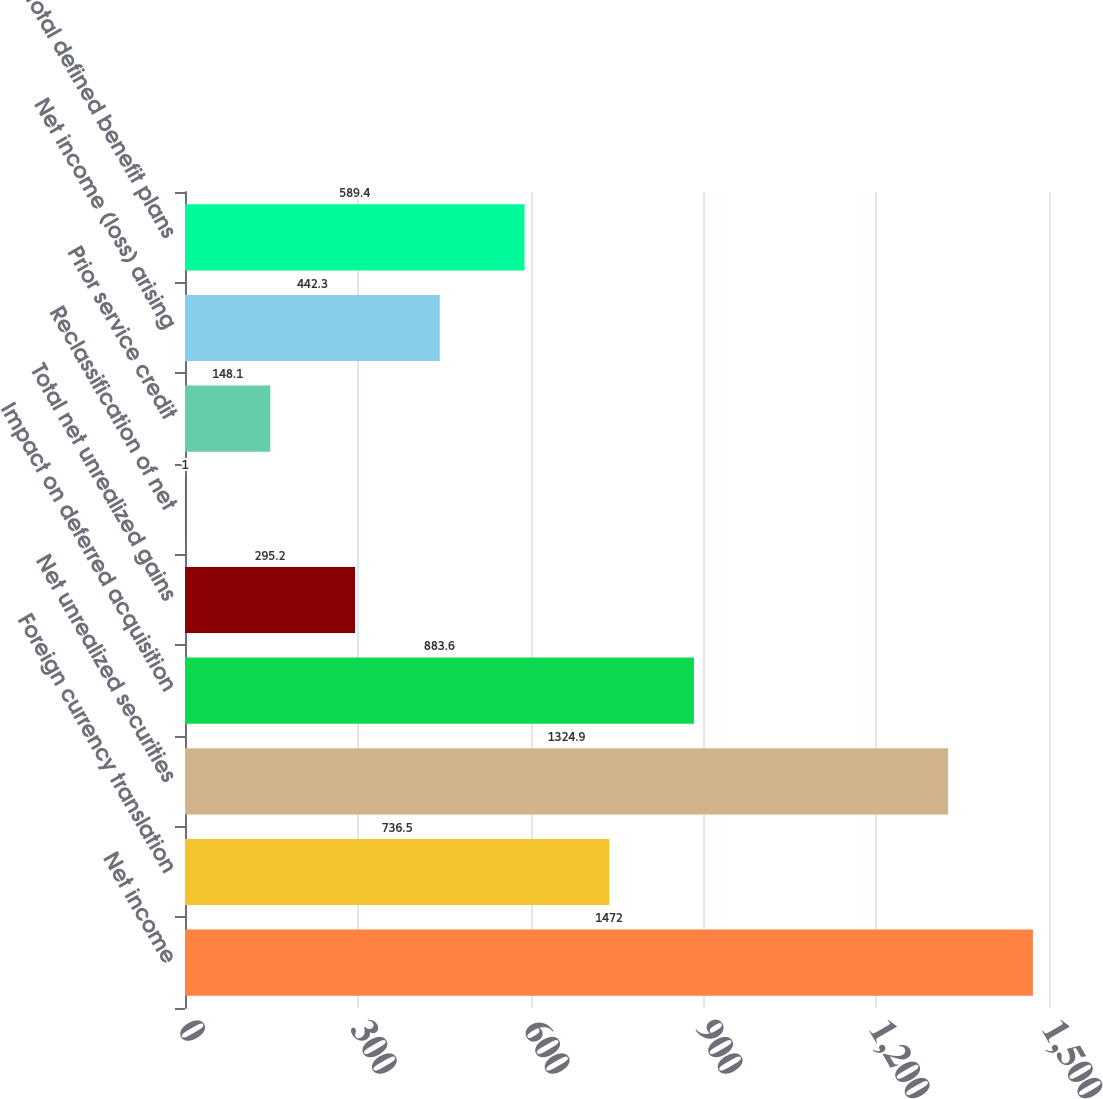Convert chart to OTSL. <chart><loc_0><loc_0><loc_500><loc_500><bar_chart><fcel>Net income<fcel>Foreign currency translation<fcel>Net unrealized securities<fcel>Impact on deferred acquisition<fcel>Total net unrealized gains<fcel>Reclassification of net<fcel>Prior service credit<fcel>Net income (loss) arising<fcel>Total defined benefit plans<nl><fcel>1472<fcel>736.5<fcel>1324.9<fcel>883.6<fcel>295.2<fcel>1<fcel>148.1<fcel>442.3<fcel>589.4<nl></chart> 